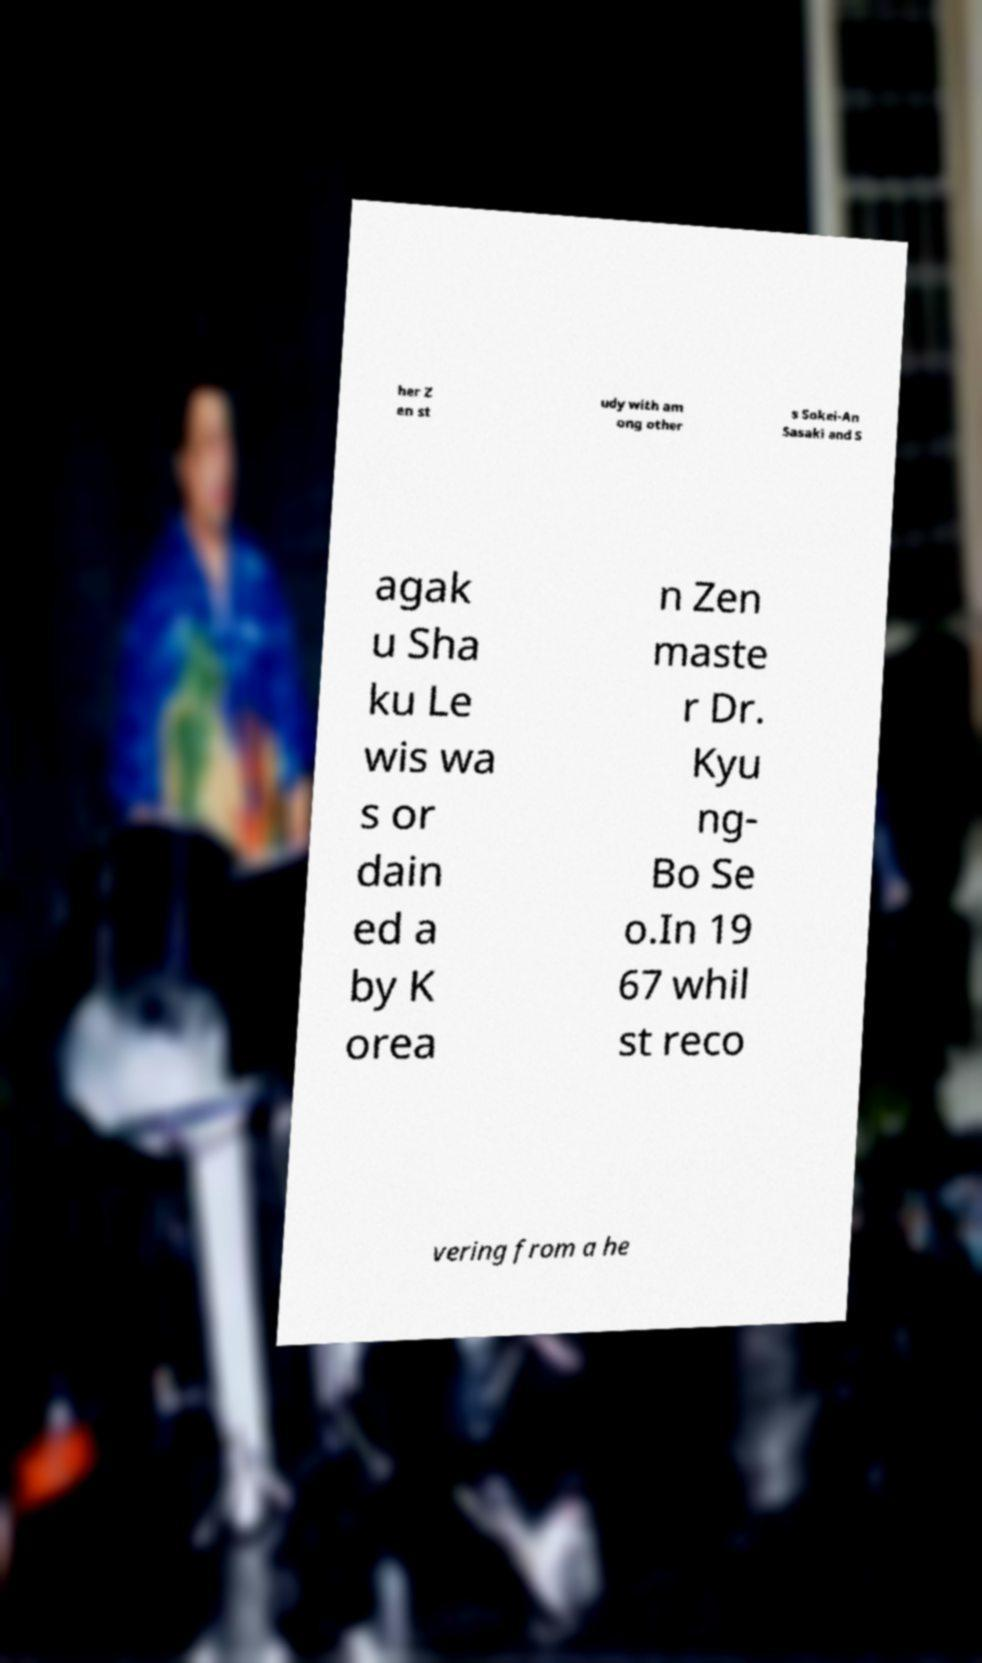Please identify and transcribe the text found in this image. her Z en st udy with am ong other s Sokei-An Sasaki and S agak u Sha ku Le wis wa s or dain ed a by K orea n Zen maste r Dr. Kyu ng- Bo Se o.In 19 67 whil st reco vering from a he 